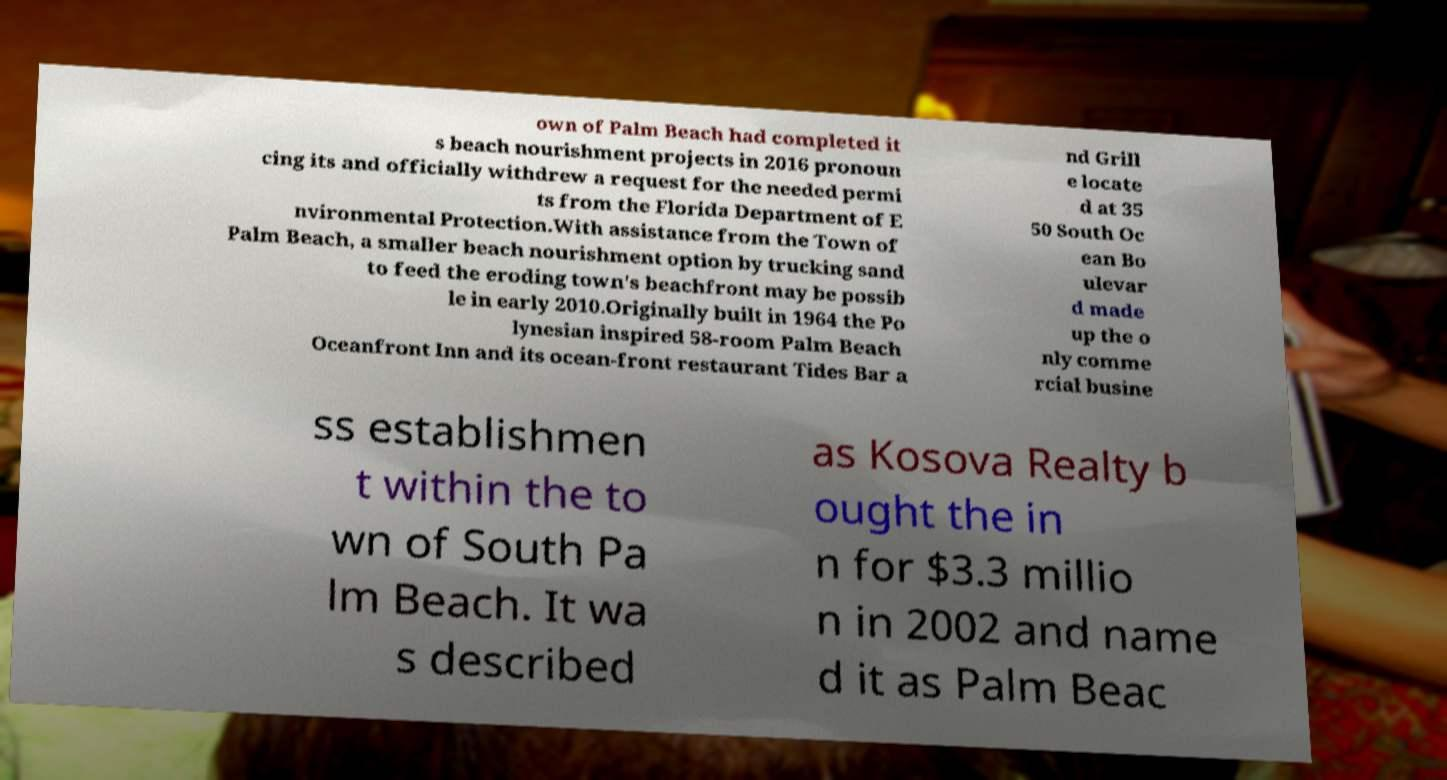For documentation purposes, I need the text within this image transcribed. Could you provide that? own of Palm Beach had completed it s beach nourishment projects in 2016 pronoun cing its and officially withdrew a request for the needed permi ts from the Florida Department of E nvironmental Protection.With assistance from the Town of Palm Beach, a smaller beach nourishment option by trucking sand to feed the eroding town's beachfront may be possib le in early 2010.Originally built in 1964 the Po lynesian inspired 58-room Palm Beach Oceanfront Inn and its ocean-front restaurant Tides Bar a nd Grill e locate d at 35 50 South Oc ean Bo ulevar d made up the o nly comme rcial busine ss establishmen t within the to wn of South Pa lm Beach. It wa s described as Kosova Realty b ought the in n for $3.3 millio n in 2002 and name d it as Palm Beac 